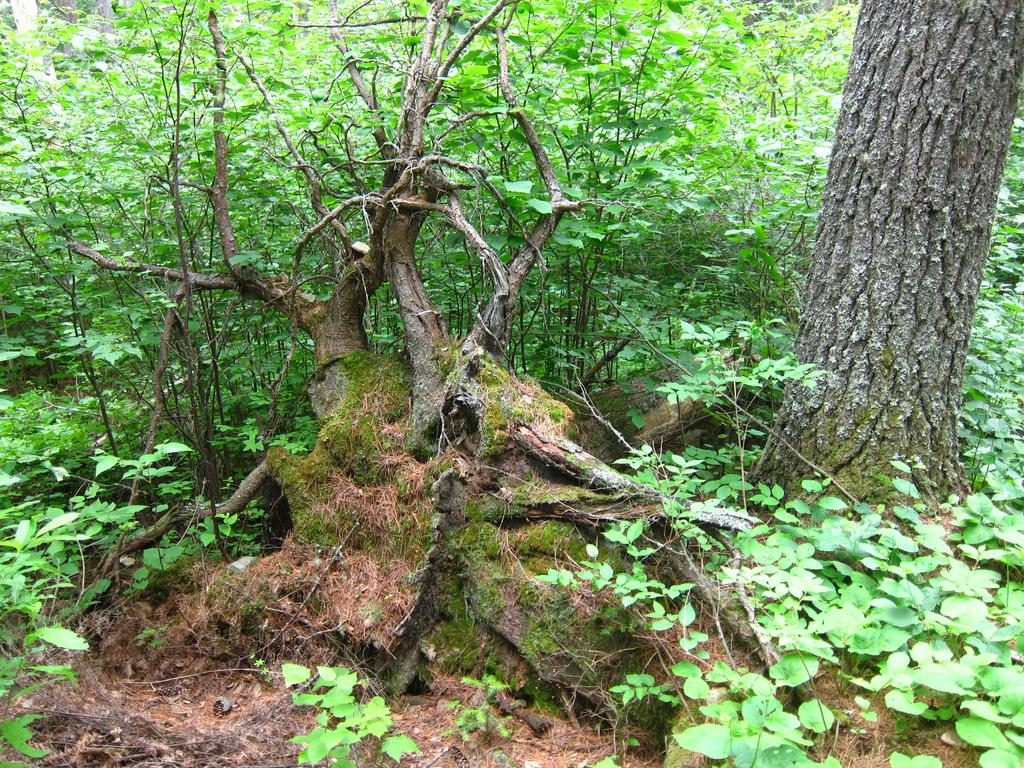What type of living organisms are present in the image? There is a group of plants in the image. What part of a tree can be seen in the image? The bark of a tree is visible in the image. What type of stamp can be seen on the bark of the tree in the image? There is no stamp present on the bark of the tree in the image. What is the cause of the plants growing in the image? The cause of the plants growing in the image cannot be determined from the image alone. 